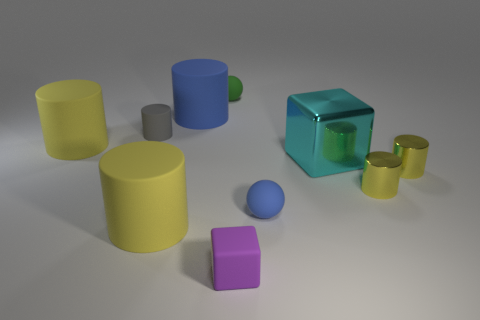There is a matte object that is right of the blue cylinder and behind the gray cylinder; what color is it? green 